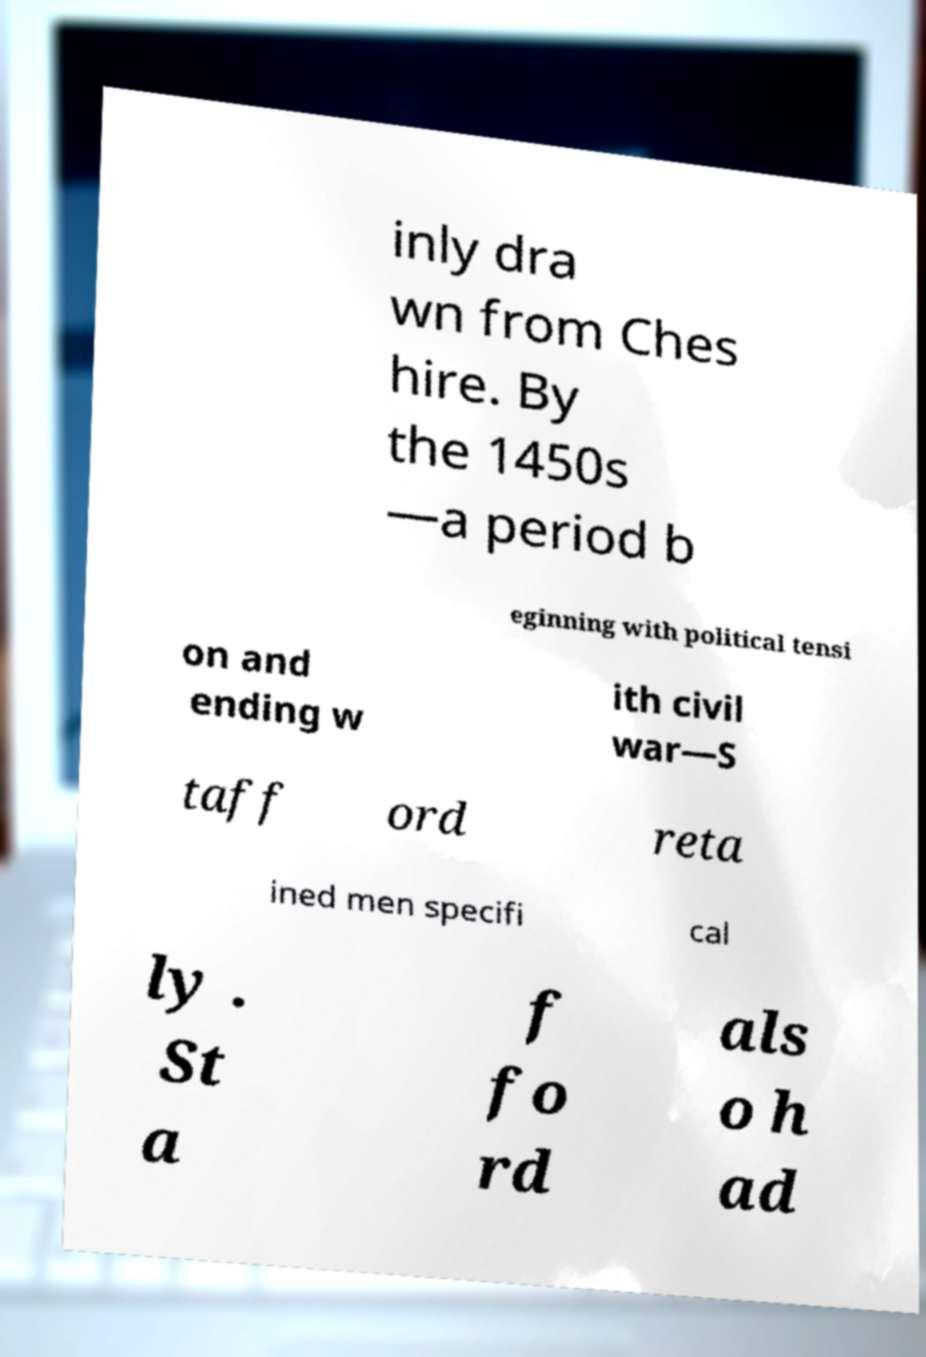Please identify and transcribe the text found in this image. inly dra wn from Ches hire. By the 1450s —a period b eginning with political tensi on and ending w ith civil war—S taff ord reta ined men specifi cal ly . St a f fo rd als o h ad 